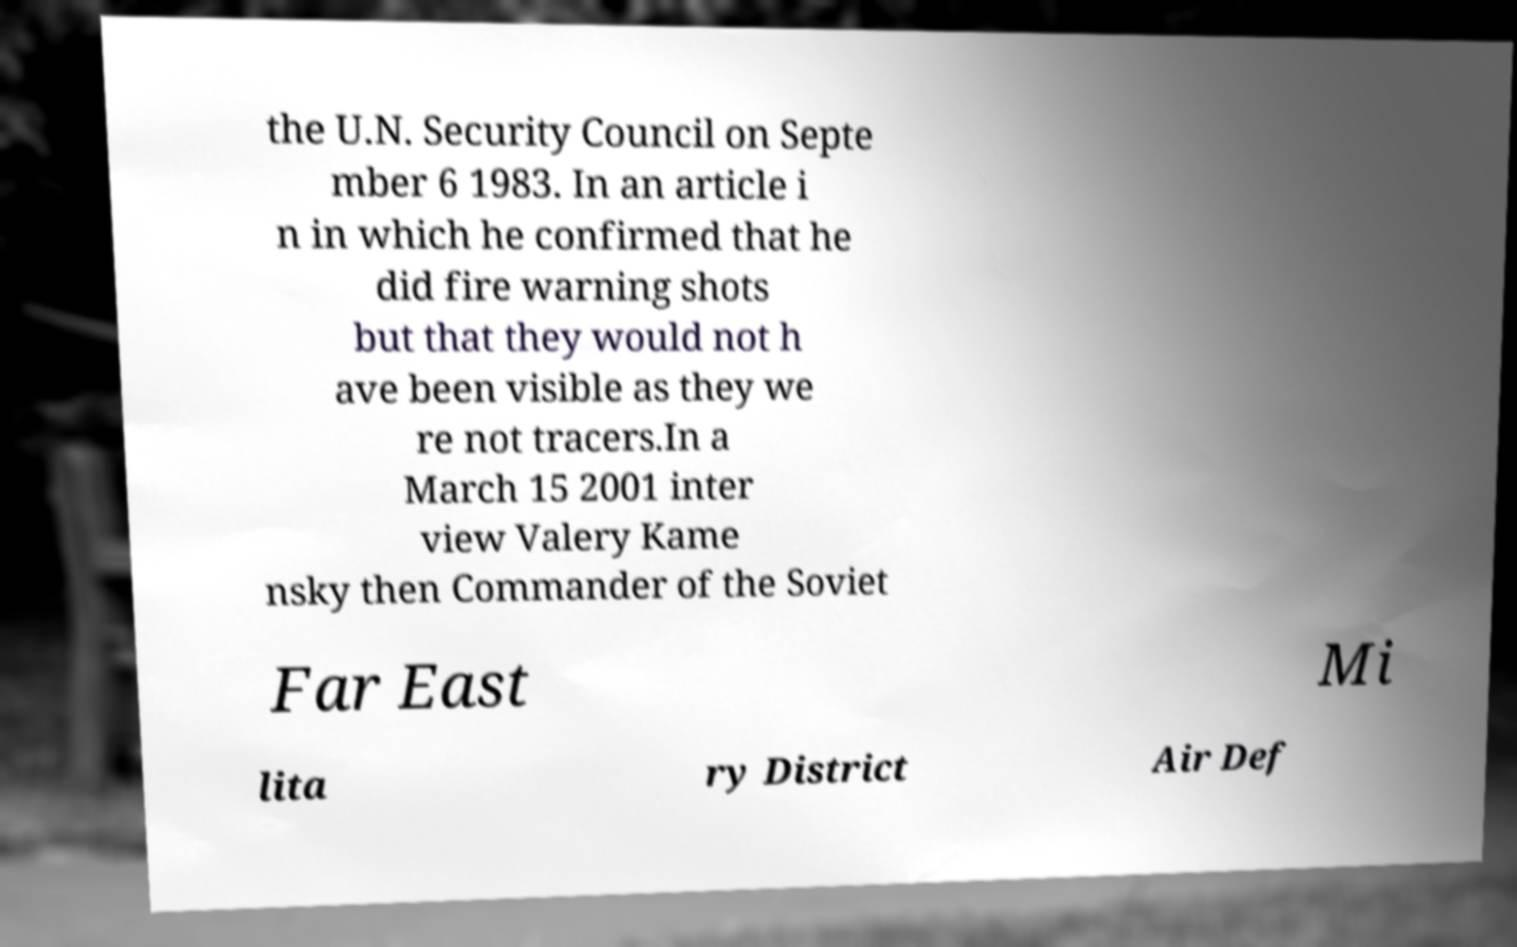Can you accurately transcribe the text from the provided image for me? the U.N. Security Council on Septe mber 6 1983. In an article i n in which he confirmed that he did fire warning shots but that they would not h ave been visible as they we re not tracers.In a March 15 2001 inter view Valery Kame nsky then Commander of the Soviet Far East Mi lita ry District Air Def 